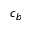Convert formula to latex. <formula><loc_0><loc_0><loc_500><loc_500>c _ { b }</formula> 